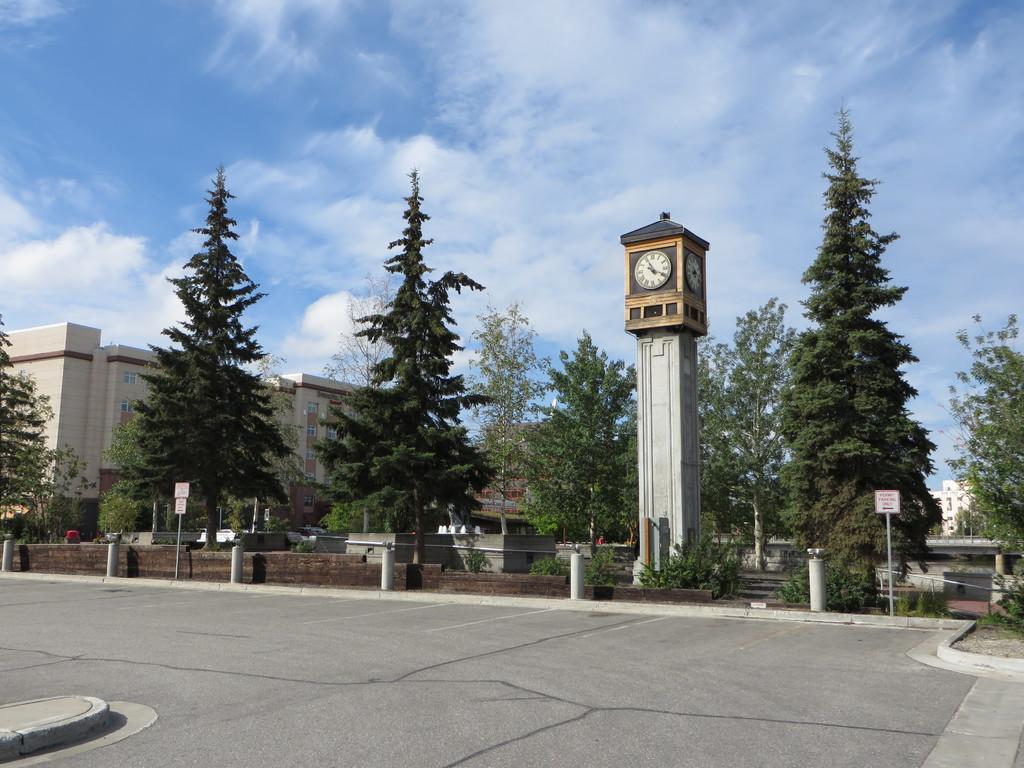Could you give a brief overview of what you see in this image? In this picture there are buildings and trees and poles and there are clocks on the tower and there are boards on the poles. At the top there is sky and there are clouds. At the bottom there is a road. 